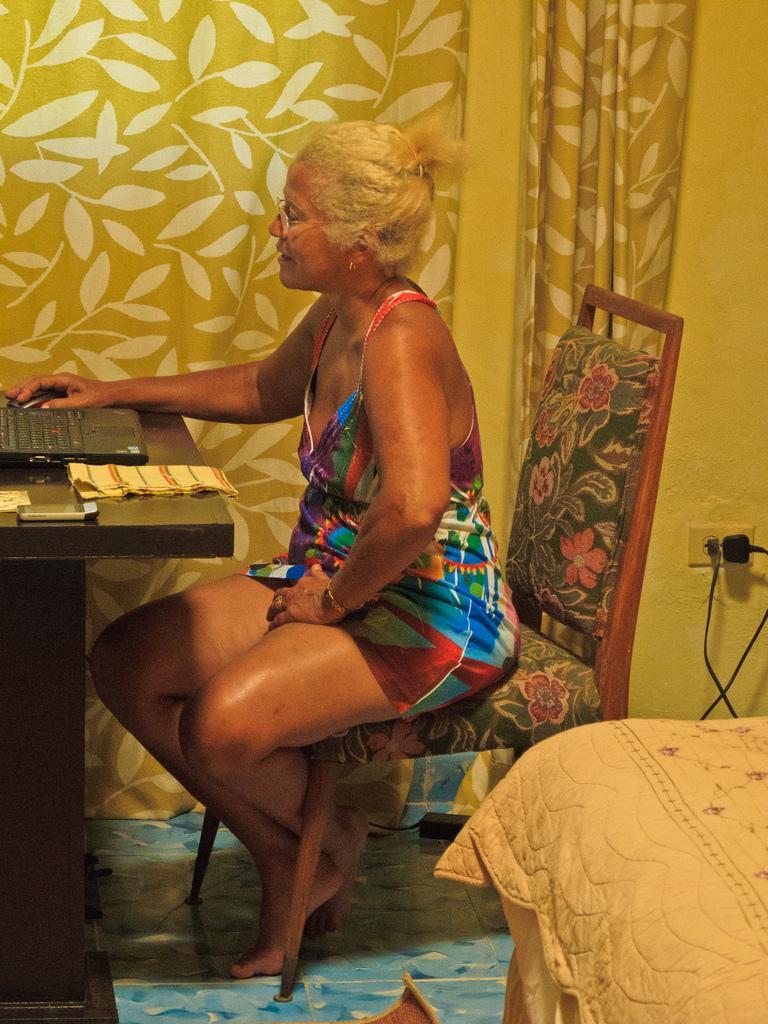How would you summarize this image in a sentence or two? There is a woman wearing specs is sitting on a chair. In front of her there is a table. On the table there is a laptop, mouse and some other items. In the back there are curtains. Also there is a socket with plugs on the wall. In the right bottom corner there is a cloth. 